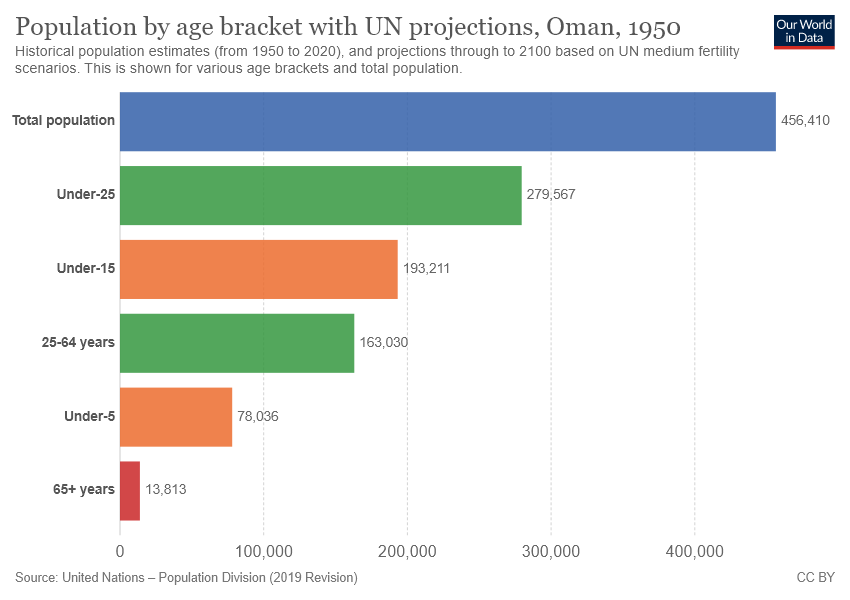Highlight a few significant elements in this photo. Find the difference between the total of two green bars and the total of two orange bars, which is 171350. According to recent statistics, the population in Oman in the age bracket under-25 is approximately 279,567. 